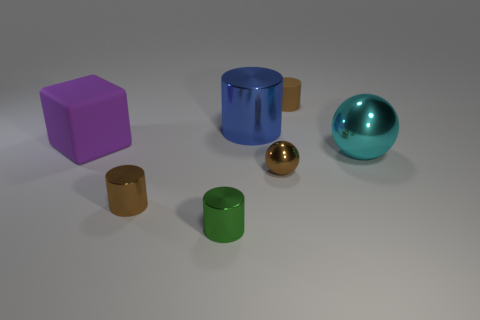Is the number of brown matte cylinders that are in front of the cyan metallic thing less than the number of small green shiny balls?
Give a very brief answer. No. What is the material of the small sphere that is the same color as the small rubber object?
Give a very brief answer. Metal. Do the blue object and the large purple block have the same material?
Your answer should be compact. No. What number of tiny brown cylinders are made of the same material as the purple cube?
Give a very brief answer. 1. The big ball that is the same material as the green object is what color?
Make the answer very short. Cyan. There is a small brown rubber object; what shape is it?
Provide a succinct answer. Cylinder. There is a brown cylinder on the right side of the green metallic cylinder; what is it made of?
Give a very brief answer. Rubber. Is there another tiny cylinder that has the same color as the small matte cylinder?
Provide a succinct answer. Yes. What is the shape of the brown matte thing that is the same size as the green metal cylinder?
Provide a short and direct response. Cylinder. There is a large shiny thing that is behind the big cyan metal ball; what is its color?
Your answer should be compact. Blue. 